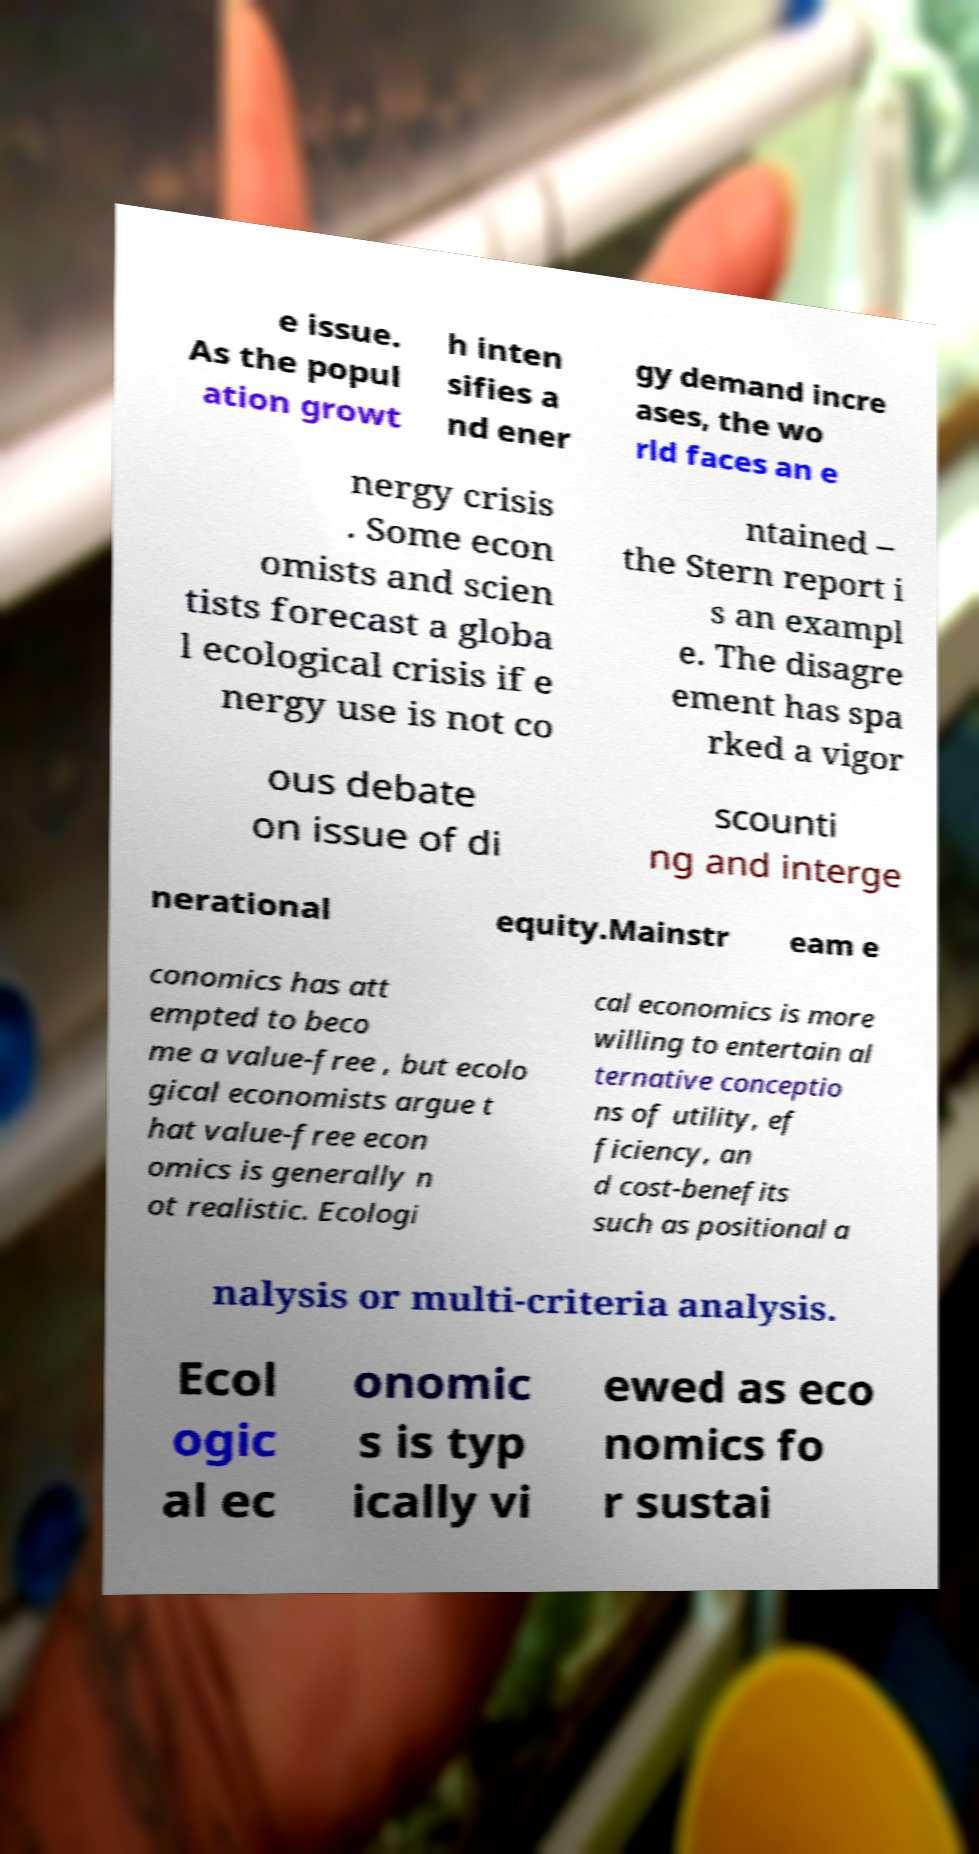Can you accurately transcribe the text from the provided image for me? e issue. As the popul ation growt h inten sifies a nd ener gy demand incre ases, the wo rld faces an e nergy crisis . Some econ omists and scien tists forecast a globa l ecological crisis if e nergy use is not co ntained – the Stern report i s an exampl e. The disagre ement has spa rked a vigor ous debate on issue of di scounti ng and interge nerational equity.Mainstr eam e conomics has att empted to beco me a value-free , but ecolo gical economists argue t hat value-free econ omics is generally n ot realistic. Ecologi cal economics is more willing to entertain al ternative conceptio ns of utility, ef ficiency, an d cost-benefits such as positional a nalysis or multi-criteria analysis. Ecol ogic al ec onomic s is typ ically vi ewed as eco nomics fo r sustai 